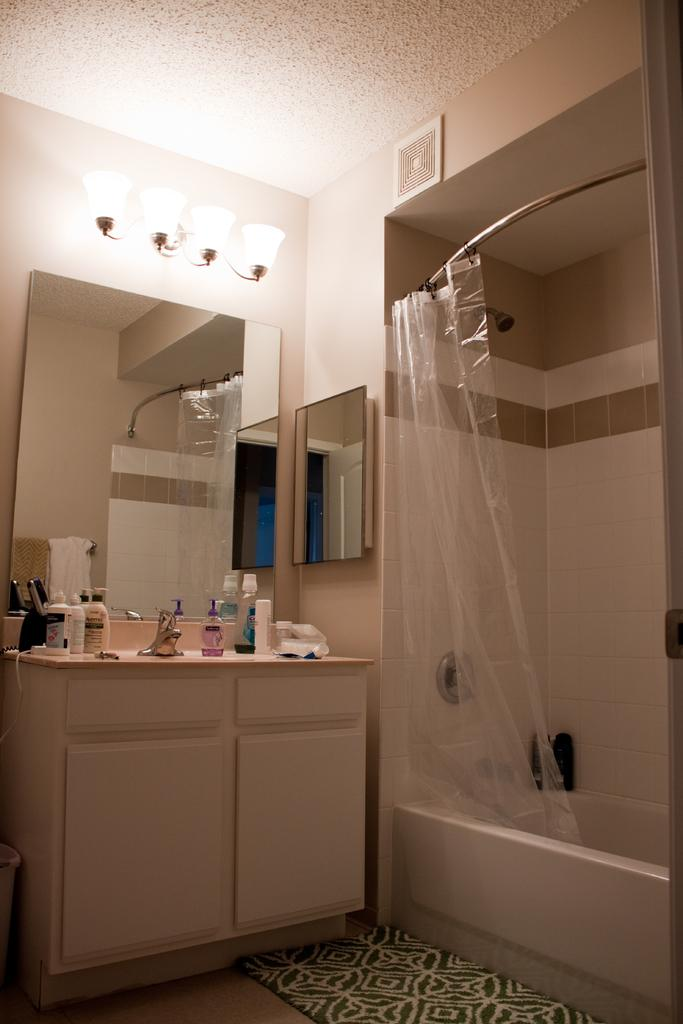What can be found in the image that is used for washing? There is a sink in the image that is used for washing. What is placed on the sink? There are bottles on the sink. What can be seen in the background of the image? There is a wall in the background of the image. What is attached to the wall? There is a mirror on the wall. What is associated with the wall? There are lights associated with the wall. What is another fixture in the image related to bathing? There is a bathtub in the image. What is located near the bathtub? There is a cover near the bathtub. What nation is represented by the flag hanging near the bathtub? There is no flag present in the image, so it is not possible to determine which nation might be represented. How does the image depict a good-bye scene? The image does not depict a good-bye scene; it shows a sink, bottles, a wall, a mirror, lights, a bathtub, and a cover. 